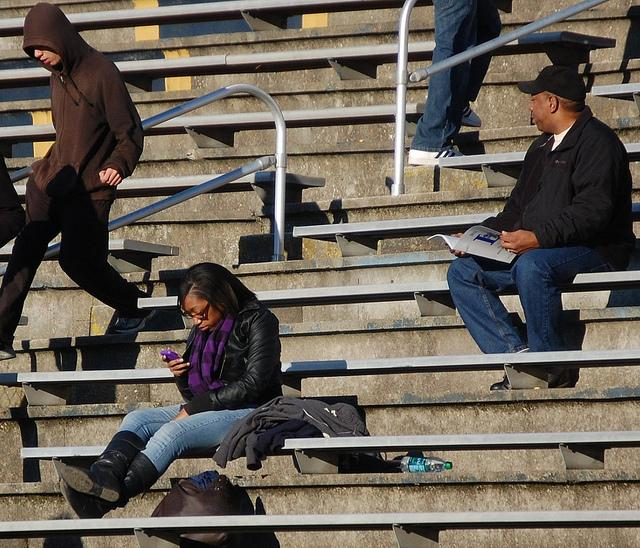What are the people sitting on?

Choices:
A) bleachers
B) beach
C) beds
D) chairs bleachers 